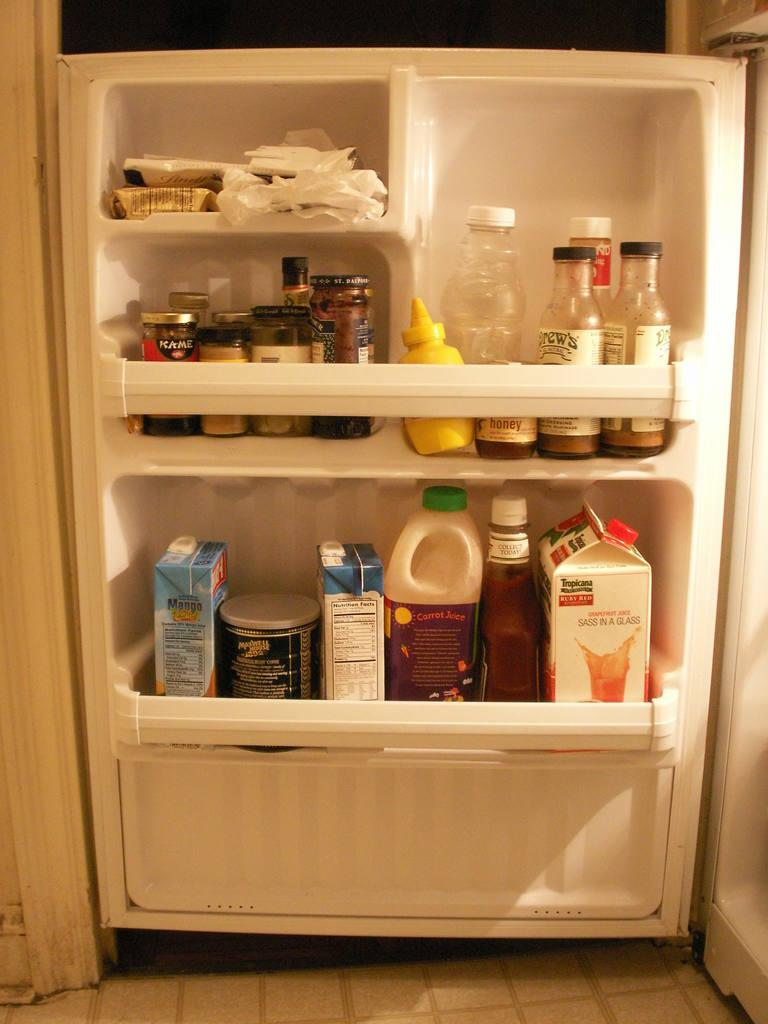<image>
Summarize the visual content of the image. An open refrigerator door with several food items hanging on it like tropicana branded orange juice on the bottom right side. 